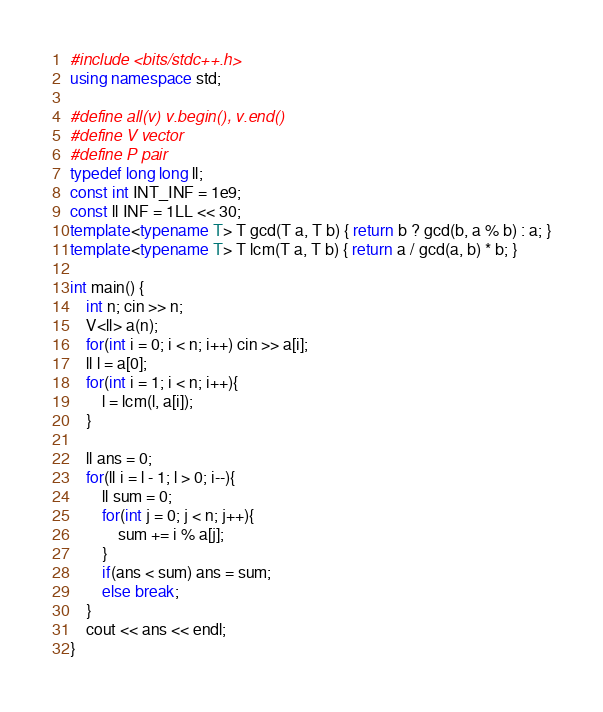Convert code to text. <code><loc_0><loc_0><loc_500><loc_500><_C++_>#include <bits/stdc++.h>
using namespace std;

#define all(v) v.begin(), v.end()
#define V vector
#define P pair
typedef long long ll;
const int INT_INF = 1e9;
const ll INF = 1LL << 30;
template<typename T> T gcd(T a, T b) { return b ? gcd(b, a % b) : a; }
template<typename T> T lcm(T a, T b) { return a / gcd(a, b) * b; }

int main() {
    int n; cin >> n;
    V<ll> a(n);
    for(int i = 0; i < n; i++) cin >> a[i];
    ll l = a[0];
    for(int i = 1; i < n; i++){
        l = lcm(l, a[i]);
    }

    ll ans = 0;
    for(ll i = l - 1; l > 0; i--){
        ll sum = 0;
        for(int j = 0; j < n; j++){
            sum += i % a[j];
        }
        if(ans < sum) ans = sum;
        else break;
    }
    cout << ans << endl;
}
</code> 